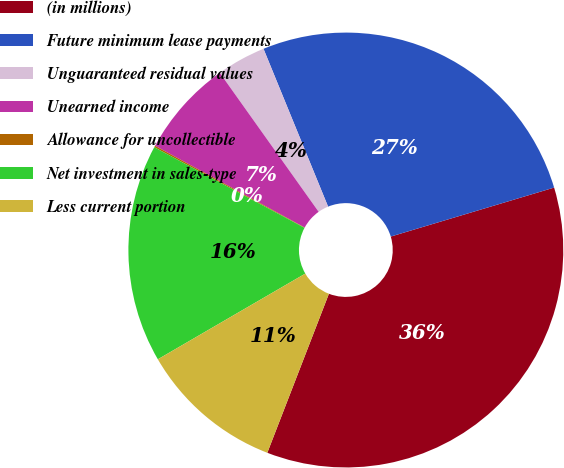Convert chart to OTSL. <chart><loc_0><loc_0><loc_500><loc_500><pie_chart><fcel>(in millions)<fcel>Future minimum lease payments<fcel>Unguaranteed residual values<fcel>Unearned income<fcel>Allowance for uncollectible<fcel>Net investment in sales-type<fcel>Less current portion<nl><fcel>35.52%<fcel>26.55%<fcel>3.66%<fcel>7.2%<fcel>0.12%<fcel>16.22%<fcel>10.74%<nl></chart> 